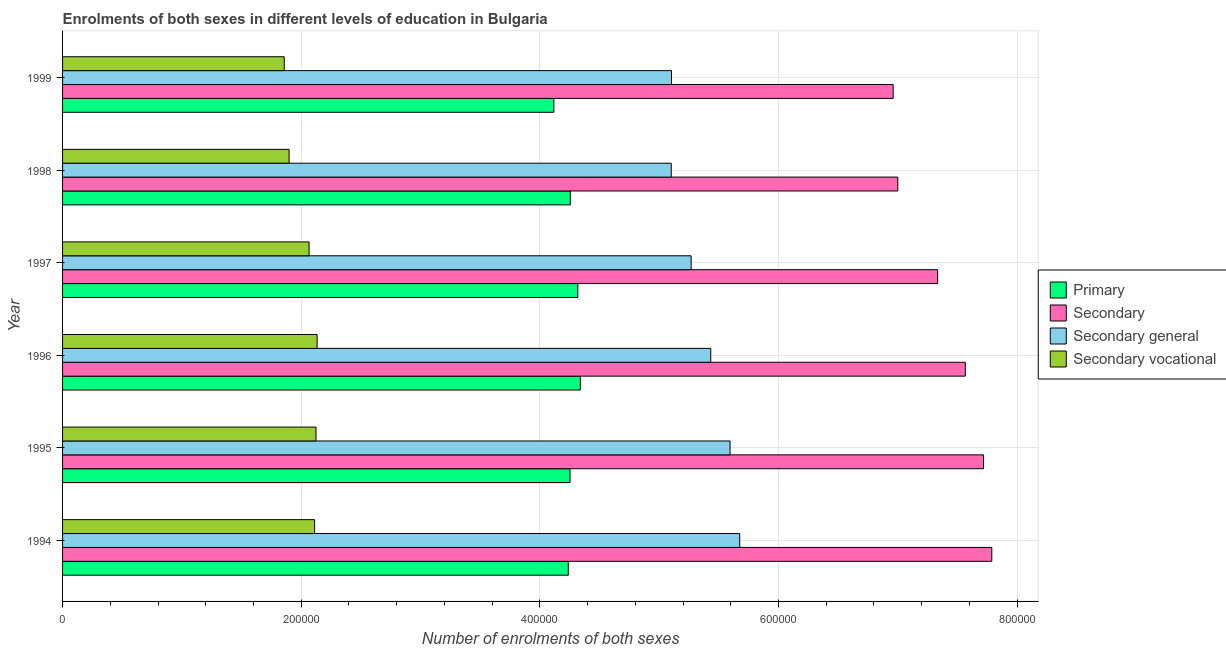How many different coloured bars are there?
Give a very brief answer. 4. How many groups of bars are there?
Offer a terse response. 6. Are the number of bars on each tick of the Y-axis equal?
Offer a very short reply. Yes. How many bars are there on the 6th tick from the bottom?
Offer a terse response. 4. What is the number of enrolments in secondary education in 1997?
Give a very brief answer. 7.33e+05. Across all years, what is the maximum number of enrolments in secondary education?
Give a very brief answer. 7.79e+05. Across all years, what is the minimum number of enrolments in secondary vocational education?
Provide a succinct answer. 1.86e+05. In which year was the number of enrolments in secondary vocational education maximum?
Give a very brief answer. 1996. What is the total number of enrolments in secondary general education in the graph?
Give a very brief answer. 3.22e+06. What is the difference between the number of enrolments in secondary general education in 1994 and that in 1996?
Keep it short and to the point. 2.43e+04. What is the difference between the number of enrolments in secondary general education in 1996 and the number of enrolments in primary education in 1998?
Give a very brief answer. 1.18e+05. What is the average number of enrolments in secondary education per year?
Offer a terse response. 7.39e+05. In the year 1998, what is the difference between the number of enrolments in secondary education and number of enrolments in primary education?
Offer a very short reply. 2.74e+05. What is the ratio of the number of enrolments in primary education in 1994 to that in 1997?
Offer a terse response. 0.98. What is the difference between the highest and the second highest number of enrolments in primary education?
Make the answer very short. 2136. What is the difference between the highest and the lowest number of enrolments in secondary education?
Give a very brief answer. 8.27e+04. What does the 4th bar from the top in 1999 represents?
Ensure brevity in your answer.  Primary. What does the 1st bar from the bottom in 1995 represents?
Your response must be concise. Primary. Are all the bars in the graph horizontal?
Make the answer very short. Yes. What is the difference between two consecutive major ticks on the X-axis?
Your answer should be very brief. 2.00e+05. Does the graph contain any zero values?
Provide a succinct answer. No. Where does the legend appear in the graph?
Make the answer very short. Center right. How many legend labels are there?
Make the answer very short. 4. How are the legend labels stacked?
Give a very brief answer. Vertical. What is the title of the graph?
Provide a succinct answer. Enrolments of both sexes in different levels of education in Bulgaria. What is the label or title of the X-axis?
Provide a short and direct response. Number of enrolments of both sexes. What is the Number of enrolments of both sexes in Primary in 1994?
Offer a terse response. 4.24e+05. What is the Number of enrolments of both sexes in Secondary in 1994?
Give a very brief answer. 7.79e+05. What is the Number of enrolments of both sexes of Secondary general in 1994?
Offer a very short reply. 5.68e+05. What is the Number of enrolments of both sexes in Secondary vocational in 1994?
Your answer should be compact. 2.11e+05. What is the Number of enrolments of both sexes of Primary in 1995?
Ensure brevity in your answer.  4.25e+05. What is the Number of enrolments of both sexes of Secondary in 1995?
Offer a very short reply. 7.72e+05. What is the Number of enrolments of both sexes of Secondary general in 1995?
Offer a very short reply. 5.59e+05. What is the Number of enrolments of both sexes of Secondary vocational in 1995?
Your response must be concise. 2.12e+05. What is the Number of enrolments of both sexes in Primary in 1996?
Your answer should be very brief. 4.34e+05. What is the Number of enrolments of both sexes in Secondary in 1996?
Provide a short and direct response. 7.57e+05. What is the Number of enrolments of both sexes in Secondary general in 1996?
Ensure brevity in your answer.  5.43e+05. What is the Number of enrolments of both sexes in Secondary vocational in 1996?
Provide a succinct answer. 2.13e+05. What is the Number of enrolments of both sexes in Primary in 1997?
Offer a very short reply. 4.32e+05. What is the Number of enrolments of both sexes of Secondary in 1997?
Make the answer very short. 7.33e+05. What is the Number of enrolments of both sexes in Secondary general in 1997?
Your response must be concise. 5.27e+05. What is the Number of enrolments of both sexes in Secondary vocational in 1997?
Your answer should be very brief. 2.07e+05. What is the Number of enrolments of both sexes in Primary in 1998?
Offer a very short reply. 4.26e+05. What is the Number of enrolments of both sexes in Secondary in 1998?
Provide a short and direct response. 7.00e+05. What is the Number of enrolments of both sexes in Secondary general in 1998?
Provide a succinct answer. 5.10e+05. What is the Number of enrolments of both sexes of Secondary vocational in 1998?
Offer a terse response. 1.90e+05. What is the Number of enrolments of both sexes in Primary in 1999?
Ensure brevity in your answer.  4.12e+05. What is the Number of enrolments of both sexes of Secondary in 1999?
Ensure brevity in your answer.  6.96e+05. What is the Number of enrolments of both sexes in Secondary general in 1999?
Ensure brevity in your answer.  5.10e+05. What is the Number of enrolments of both sexes in Secondary vocational in 1999?
Keep it short and to the point. 1.86e+05. Across all years, what is the maximum Number of enrolments of both sexes in Primary?
Your answer should be very brief. 4.34e+05. Across all years, what is the maximum Number of enrolments of both sexes of Secondary?
Ensure brevity in your answer.  7.79e+05. Across all years, what is the maximum Number of enrolments of both sexes of Secondary general?
Your response must be concise. 5.68e+05. Across all years, what is the maximum Number of enrolments of both sexes of Secondary vocational?
Make the answer very short. 2.13e+05. Across all years, what is the minimum Number of enrolments of both sexes of Primary?
Make the answer very short. 4.12e+05. Across all years, what is the minimum Number of enrolments of both sexes of Secondary?
Your answer should be very brief. 6.96e+05. Across all years, what is the minimum Number of enrolments of both sexes of Secondary general?
Ensure brevity in your answer.  5.10e+05. Across all years, what is the minimum Number of enrolments of both sexes in Secondary vocational?
Ensure brevity in your answer.  1.86e+05. What is the total Number of enrolments of both sexes of Primary in the graph?
Your response must be concise. 2.55e+06. What is the total Number of enrolments of both sexes of Secondary in the graph?
Ensure brevity in your answer.  4.44e+06. What is the total Number of enrolments of both sexes in Secondary general in the graph?
Your response must be concise. 3.22e+06. What is the total Number of enrolments of both sexes of Secondary vocational in the graph?
Make the answer very short. 1.22e+06. What is the difference between the Number of enrolments of both sexes of Primary in 1994 and that in 1995?
Offer a very short reply. -1468. What is the difference between the Number of enrolments of both sexes in Secondary in 1994 and that in 1995?
Give a very brief answer. 6939. What is the difference between the Number of enrolments of both sexes in Secondary general in 1994 and that in 1995?
Ensure brevity in your answer.  8105. What is the difference between the Number of enrolments of both sexes in Secondary vocational in 1994 and that in 1995?
Offer a terse response. -1166. What is the difference between the Number of enrolments of both sexes in Primary in 1994 and that in 1996?
Your answer should be compact. -1.01e+04. What is the difference between the Number of enrolments of both sexes of Secondary in 1994 and that in 1996?
Give a very brief answer. 2.22e+04. What is the difference between the Number of enrolments of both sexes of Secondary general in 1994 and that in 1996?
Ensure brevity in your answer.  2.43e+04. What is the difference between the Number of enrolments of both sexes of Secondary vocational in 1994 and that in 1996?
Your response must be concise. -2102. What is the difference between the Number of enrolments of both sexes of Primary in 1994 and that in 1997?
Provide a short and direct response. -7972. What is the difference between the Number of enrolments of both sexes in Secondary in 1994 and that in 1997?
Keep it short and to the point. 4.54e+04. What is the difference between the Number of enrolments of both sexes of Secondary general in 1994 and that in 1997?
Your answer should be compact. 4.07e+04. What is the difference between the Number of enrolments of both sexes of Secondary vocational in 1994 and that in 1997?
Offer a terse response. 4665. What is the difference between the Number of enrolments of both sexes of Primary in 1994 and that in 1998?
Make the answer very short. -1693. What is the difference between the Number of enrolments of both sexes in Secondary in 1994 and that in 1998?
Give a very brief answer. 7.88e+04. What is the difference between the Number of enrolments of both sexes of Secondary general in 1994 and that in 1998?
Make the answer very short. 5.74e+04. What is the difference between the Number of enrolments of both sexes in Secondary vocational in 1994 and that in 1998?
Make the answer very short. 2.14e+04. What is the difference between the Number of enrolments of both sexes in Primary in 1994 and that in 1999?
Give a very brief answer. 1.21e+04. What is the difference between the Number of enrolments of both sexes of Secondary in 1994 and that in 1999?
Provide a short and direct response. 8.27e+04. What is the difference between the Number of enrolments of both sexes of Secondary general in 1994 and that in 1999?
Give a very brief answer. 5.72e+04. What is the difference between the Number of enrolments of both sexes in Secondary vocational in 1994 and that in 1999?
Offer a very short reply. 2.55e+04. What is the difference between the Number of enrolments of both sexes in Primary in 1995 and that in 1996?
Keep it short and to the point. -8640. What is the difference between the Number of enrolments of both sexes in Secondary in 1995 and that in 1996?
Provide a succinct answer. 1.53e+04. What is the difference between the Number of enrolments of both sexes of Secondary general in 1995 and that in 1996?
Offer a very short reply. 1.62e+04. What is the difference between the Number of enrolments of both sexes of Secondary vocational in 1995 and that in 1996?
Provide a succinct answer. -936. What is the difference between the Number of enrolments of both sexes of Primary in 1995 and that in 1997?
Your answer should be compact. -6504. What is the difference between the Number of enrolments of both sexes in Secondary in 1995 and that in 1997?
Provide a succinct answer. 3.84e+04. What is the difference between the Number of enrolments of both sexes in Secondary general in 1995 and that in 1997?
Keep it short and to the point. 3.26e+04. What is the difference between the Number of enrolments of both sexes in Secondary vocational in 1995 and that in 1997?
Give a very brief answer. 5831. What is the difference between the Number of enrolments of both sexes of Primary in 1995 and that in 1998?
Keep it short and to the point. -225. What is the difference between the Number of enrolments of both sexes in Secondary in 1995 and that in 1998?
Your answer should be very brief. 7.18e+04. What is the difference between the Number of enrolments of both sexes of Secondary general in 1995 and that in 1998?
Provide a succinct answer. 4.93e+04. What is the difference between the Number of enrolments of both sexes in Secondary vocational in 1995 and that in 1998?
Provide a succinct answer. 2.26e+04. What is the difference between the Number of enrolments of both sexes of Primary in 1995 and that in 1999?
Give a very brief answer. 1.36e+04. What is the difference between the Number of enrolments of both sexes of Secondary in 1995 and that in 1999?
Keep it short and to the point. 7.57e+04. What is the difference between the Number of enrolments of both sexes of Secondary general in 1995 and that in 1999?
Offer a terse response. 4.91e+04. What is the difference between the Number of enrolments of both sexes of Secondary vocational in 1995 and that in 1999?
Provide a succinct answer. 2.66e+04. What is the difference between the Number of enrolments of both sexes of Primary in 1996 and that in 1997?
Offer a very short reply. 2136. What is the difference between the Number of enrolments of both sexes in Secondary in 1996 and that in 1997?
Give a very brief answer. 2.32e+04. What is the difference between the Number of enrolments of both sexes of Secondary general in 1996 and that in 1997?
Provide a succinct answer. 1.64e+04. What is the difference between the Number of enrolments of both sexes in Secondary vocational in 1996 and that in 1997?
Give a very brief answer. 6767. What is the difference between the Number of enrolments of both sexes of Primary in 1996 and that in 1998?
Your response must be concise. 8415. What is the difference between the Number of enrolments of both sexes of Secondary in 1996 and that in 1998?
Offer a terse response. 5.66e+04. What is the difference between the Number of enrolments of both sexes in Secondary general in 1996 and that in 1998?
Offer a terse response. 3.31e+04. What is the difference between the Number of enrolments of both sexes of Secondary vocational in 1996 and that in 1998?
Ensure brevity in your answer.  2.35e+04. What is the difference between the Number of enrolments of both sexes in Primary in 1996 and that in 1999?
Provide a succinct answer. 2.22e+04. What is the difference between the Number of enrolments of both sexes of Secondary in 1996 and that in 1999?
Keep it short and to the point. 6.05e+04. What is the difference between the Number of enrolments of both sexes of Secondary general in 1996 and that in 1999?
Provide a succinct answer. 3.29e+04. What is the difference between the Number of enrolments of both sexes in Secondary vocational in 1996 and that in 1999?
Your answer should be compact. 2.76e+04. What is the difference between the Number of enrolments of both sexes of Primary in 1997 and that in 1998?
Keep it short and to the point. 6279. What is the difference between the Number of enrolments of both sexes in Secondary in 1997 and that in 1998?
Your answer should be compact. 3.34e+04. What is the difference between the Number of enrolments of both sexes in Secondary general in 1997 and that in 1998?
Your answer should be compact. 1.67e+04. What is the difference between the Number of enrolments of both sexes of Secondary vocational in 1997 and that in 1998?
Offer a very short reply. 1.67e+04. What is the difference between the Number of enrolments of both sexes in Primary in 1997 and that in 1999?
Your response must be concise. 2.01e+04. What is the difference between the Number of enrolments of both sexes in Secondary in 1997 and that in 1999?
Your response must be concise. 3.73e+04. What is the difference between the Number of enrolments of both sexes of Secondary general in 1997 and that in 1999?
Give a very brief answer. 1.65e+04. What is the difference between the Number of enrolments of both sexes of Secondary vocational in 1997 and that in 1999?
Provide a short and direct response. 2.08e+04. What is the difference between the Number of enrolments of both sexes of Primary in 1998 and that in 1999?
Provide a short and direct response. 1.38e+04. What is the difference between the Number of enrolments of both sexes in Secondary in 1998 and that in 1999?
Offer a terse response. 3884. What is the difference between the Number of enrolments of both sexes of Secondary general in 1998 and that in 1999?
Your answer should be compact. -215. What is the difference between the Number of enrolments of both sexes of Secondary vocational in 1998 and that in 1999?
Your response must be concise. 4099. What is the difference between the Number of enrolments of both sexes of Primary in 1994 and the Number of enrolments of both sexes of Secondary in 1995?
Provide a succinct answer. -3.48e+05. What is the difference between the Number of enrolments of both sexes in Primary in 1994 and the Number of enrolments of both sexes in Secondary general in 1995?
Your response must be concise. -1.36e+05. What is the difference between the Number of enrolments of both sexes in Primary in 1994 and the Number of enrolments of both sexes in Secondary vocational in 1995?
Your response must be concise. 2.11e+05. What is the difference between the Number of enrolments of both sexes in Secondary in 1994 and the Number of enrolments of both sexes in Secondary general in 1995?
Your answer should be very brief. 2.19e+05. What is the difference between the Number of enrolments of both sexes of Secondary in 1994 and the Number of enrolments of both sexes of Secondary vocational in 1995?
Provide a short and direct response. 5.66e+05. What is the difference between the Number of enrolments of both sexes of Secondary general in 1994 and the Number of enrolments of both sexes of Secondary vocational in 1995?
Your answer should be very brief. 3.55e+05. What is the difference between the Number of enrolments of both sexes of Primary in 1994 and the Number of enrolments of both sexes of Secondary in 1996?
Give a very brief answer. -3.33e+05. What is the difference between the Number of enrolments of both sexes in Primary in 1994 and the Number of enrolments of both sexes in Secondary general in 1996?
Your response must be concise. -1.19e+05. What is the difference between the Number of enrolments of both sexes in Primary in 1994 and the Number of enrolments of both sexes in Secondary vocational in 1996?
Your response must be concise. 2.10e+05. What is the difference between the Number of enrolments of both sexes in Secondary in 1994 and the Number of enrolments of both sexes in Secondary general in 1996?
Make the answer very short. 2.36e+05. What is the difference between the Number of enrolments of both sexes in Secondary in 1994 and the Number of enrolments of both sexes in Secondary vocational in 1996?
Offer a terse response. 5.65e+05. What is the difference between the Number of enrolments of both sexes in Secondary general in 1994 and the Number of enrolments of both sexes in Secondary vocational in 1996?
Offer a very short reply. 3.54e+05. What is the difference between the Number of enrolments of both sexes in Primary in 1994 and the Number of enrolments of both sexes in Secondary in 1997?
Provide a succinct answer. -3.10e+05. What is the difference between the Number of enrolments of both sexes in Primary in 1994 and the Number of enrolments of both sexes in Secondary general in 1997?
Your answer should be very brief. -1.03e+05. What is the difference between the Number of enrolments of both sexes in Primary in 1994 and the Number of enrolments of both sexes in Secondary vocational in 1997?
Offer a very short reply. 2.17e+05. What is the difference between the Number of enrolments of both sexes of Secondary in 1994 and the Number of enrolments of both sexes of Secondary general in 1997?
Give a very brief answer. 2.52e+05. What is the difference between the Number of enrolments of both sexes of Secondary in 1994 and the Number of enrolments of both sexes of Secondary vocational in 1997?
Your answer should be compact. 5.72e+05. What is the difference between the Number of enrolments of both sexes of Secondary general in 1994 and the Number of enrolments of both sexes of Secondary vocational in 1997?
Ensure brevity in your answer.  3.61e+05. What is the difference between the Number of enrolments of both sexes in Primary in 1994 and the Number of enrolments of both sexes in Secondary in 1998?
Your response must be concise. -2.76e+05. What is the difference between the Number of enrolments of both sexes in Primary in 1994 and the Number of enrolments of both sexes in Secondary general in 1998?
Offer a very short reply. -8.63e+04. What is the difference between the Number of enrolments of both sexes of Primary in 1994 and the Number of enrolments of both sexes of Secondary vocational in 1998?
Your response must be concise. 2.34e+05. What is the difference between the Number of enrolments of both sexes of Secondary in 1994 and the Number of enrolments of both sexes of Secondary general in 1998?
Provide a succinct answer. 2.69e+05. What is the difference between the Number of enrolments of both sexes in Secondary in 1994 and the Number of enrolments of both sexes in Secondary vocational in 1998?
Your response must be concise. 5.89e+05. What is the difference between the Number of enrolments of both sexes in Secondary general in 1994 and the Number of enrolments of both sexes in Secondary vocational in 1998?
Keep it short and to the point. 3.78e+05. What is the difference between the Number of enrolments of both sexes in Primary in 1994 and the Number of enrolments of both sexes in Secondary in 1999?
Provide a succinct answer. -2.72e+05. What is the difference between the Number of enrolments of both sexes in Primary in 1994 and the Number of enrolments of both sexes in Secondary general in 1999?
Give a very brief answer. -8.65e+04. What is the difference between the Number of enrolments of both sexes of Primary in 1994 and the Number of enrolments of both sexes of Secondary vocational in 1999?
Ensure brevity in your answer.  2.38e+05. What is the difference between the Number of enrolments of both sexes in Secondary in 1994 and the Number of enrolments of both sexes in Secondary general in 1999?
Your response must be concise. 2.68e+05. What is the difference between the Number of enrolments of both sexes of Secondary in 1994 and the Number of enrolments of both sexes of Secondary vocational in 1999?
Give a very brief answer. 5.93e+05. What is the difference between the Number of enrolments of both sexes in Secondary general in 1994 and the Number of enrolments of both sexes in Secondary vocational in 1999?
Provide a succinct answer. 3.82e+05. What is the difference between the Number of enrolments of both sexes in Primary in 1995 and the Number of enrolments of both sexes in Secondary in 1996?
Keep it short and to the point. -3.31e+05. What is the difference between the Number of enrolments of both sexes in Primary in 1995 and the Number of enrolments of both sexes in Secondary general in 1996?
Offer a terse response. -1.18e+05. What is the difference between the Number of enrolments of both sexes in Primary in 1995 and the Number of enrolments of both sexes in Secondary vocational in 1996?
Your answer should be compact. 2.12e+05. What is the difference between the Number of enrolments of both sexes of Secondary in 1995 and the Number of enrolments of both sexes of Secondary general in 1996?
Your answer should be very brief. 2.29e+05. What is the difference between the Number of enrolments of both sexes in Secondary in 1995 and the Number of enrolments of both sexes in Secondary vocational in 1996?
Provide a succinct answer. 5.58e+05. What is the difference between the Number of enrolments of both sexes of Secondary general in 1995 and the Number of enrolments of both sexes of Secondary vocational in 1996?
Provide a short and direct response. 3.46e+05. What is the difference between the Number of enrolments of both sexes of Primary in 1995 and the Number of enrolments of both sexes of Secondary in 1997?
Your response must be concise. -3.08e+05. What is the difference between the Number of enrolments of both sexes in Primary in 1995 and the Number of enrolments of both sexes in Secondary general in 1997?
Keep it short and to the point. -1.02e+05. What is the difference between the Number of enrolments of both sexes of Primary in 1995 and the Number of enrolments of both sexes of Secondary vocational in 1997?
Your answer should be compact. 2.19e+05. What is the difference between the Number of enrolments of both sexes of Secondary in 1995 and the Number of enrolments of both sexes of Secondary general in 1997?
Make the answer very short. 2.45e+05. What is the difference between the Number of enrolments of both sexes of Secondary in 1995 and the Number of enrolments of both sexes of Secondary vocational in 1997?
Ensure brevity in your answer.  5.65e+05. What is the difference between the Number of enrolments of both sexes in Secondary general in 1995 and the Number of enrolments of both sexes in Secondary vocational in 1997?
Provide a succinct answer. 3.53e+05. What is the difference between the Number of enrolments of both sexes of Primary in 1995 and the Number of enrolments of both sexes of Secondary in 1998?
Offer a terse response. -2.75e+05. What is the difference between the Number of enrolments of both sexes of Primary in 1995 and the Number of enrolments of both sexes of Secondary general in 1998?
Make the answer very short. -8.48e+04. What is the difference between the Number of enrolments of both sexes in Primary in 1995 and the Number of enrolments of both sexes in Secondary vocational in 1998?
Your response must be concise. 2.35e+05. What is the difference between the Number of enrolments of both sexes of Secondary in 1995 and the Number of enrolments of both sexes of Secondary general in 1998?
Offer a terse response. 2.62e+05. What is the difference between the Number of enrolments of both sexes in Secondary in 1995 and the Number of enrolments of both sexes in Secondary vocational in 1998?
Make the answer very short. 5.82e+05. What is the difference between the Number of enrolments of both sexes in Secondary general in 1995 and the Number of enrolments of both sexes in Secondary vocational in 1998?
Provide a short and direct response. 3.70e+05. What is the difference between the Number of enrolments of both sexes in Primary in 1995 and the Number of enrolments of both sexes in Secondary in 1999?
Your answer should be compact. -2.71e+05. What is the difference between the Number of enrolments of both sexes in Primary in 1995 and the Number of enrolments of both sexes in Secondary general in 1999?
Make the answer very short. -8.50e+04. What is the difference between the Number of enrolments of both sexes in Primary in 1995 and the Number of enrolments of both sexes in Secondary vocational in 1999?
Give a very brief answer. 2.40e+05. What is the difference between the Number of enrolments of both sexes of Secondary in 1995 and the Number of enrolments of both sexes of Secondary general in 1999?
Your answer should be very brief. 2.61e+05. What is the difference between the Number of enrolments of both sexes of Secondary in 1995 and the Number of enrolments of both sexes of Secondary vocational in 1999?
Offer a very short reply. 5.86e+05. What is the difference between the Number of enrolments of both sexes of Secondary general in 1995 and the Number of enrolments of both sexes of Secondary vocational in 1999?
Offer a very short reply. 3.74e+05. What is the difference between the Number of enrolments of both sexes of Primary in 1996 and the Number of enrolments of both sexes of Secondary in 1997?
Your response must be concise. -2.99e+05. What is the difference between the Number of enrolments of both sexes of Primary in 1996 and the Number of enrolments of both sexes of Secondary general in 1997?
Your response must be concise. -9.29e+04. What is the difference between the Number of enrolments of both sexes of Primary in 1996 and the Number of enrolments of both sexes of Secondary vocational in 1997?
Make the answer very short. 2.27e+05. What is the difference between the Number of enrolments of both sexes of Secondary in 1996 and the Number of enrolments of both sexes of Secondary general in 1997?
Offer a terse response. 2.30e+05. What is the difference between the Number of enrolments of both sexes in Secondary in 1996 and the Number of enrolments of both sexes in Secondary vocational in 1997?
Offer a very short reply. 5.50e+05. What is the difference between the Number of enrolments of both sexes in Secondary general in 1996 and the Number of enrolments of both sexes in Secondary vocational in 1997?
Give a very brief answer. 3.37e+05. What is the difference between the Number of enrolments of both sexes of Primary in 1996 and the Number of enrolments of both sexes of Secondary in 1998?
Provide a short and direct response. -2.66e+05. What is the difference between the Number of enrolments of both sexes in Primary in 1996 and the Number of enrolments of both sexes in Secondary general in 1998?
Keep it short and to the point. -7.62e+04. What is the difference between the Number of enrolments of both sexes in Primary in 1996 and the Number of enrolments of both sexes in Secondary vocational in 1998?
Give a very brief answer. 2.44e+05. What is the difference between the Number of enrolments of both sexes in Secondary in 1996 and the Number of enrolments of both sexes in Secondary general in 1998?
Provide a succinct answer. 2.46e+05. What is the difference between the Number of enrolments of both sexes in Secondary in 1996 and the Number of enrolments of both sexes in Secondary vocational in 1998?
Keep it short and to the point. 5.67e+05. What is the difference between the Number of enrolments of both sexes of Secondary general in 1996 and the Number of enrolments of both sexes of Secondary vocational in 1998?
Provide a succinct answer. 3.53e+05. What is the difference between the Number of enrolments of both sexes in Primary in 1996 and the Number of enrolments of both sexes in Secondary in 1999?
Offer a very short reply. -2.62e+05. What is the difference between the Number of enrolments of both sexes of Primary in 1996 and the Number of enrolments of both sexes of Secondary general in 1999?
Give a very brief answer. -7.64e+04. What is the difference between the Number of enrolments of both sexes of Primary in 1996 and the Number of enrolments of both sexes of Secondary vocational in 1999?
Offer a very short reply. 2.48e+05. What is the difference between the Number of enrolments of both sexes of Secondary in 1996 and the Number of enrolments of both sexes of Secondary general in 1999?
Provide a succinct answer. 2.46e+05. What is the difference between the Number of enrolments of both sexes in Secondary in 1996 and the Number of enrolments of both sexes in Secondary vocational in 1999?
Make the answer very short. 5.71e+05. What is the difference between the Number of enrolments of both sexes of Secondary general in 1996 and the Number of enrolments of both sexes of Secondary vocational in 1999?
Give a very brief answer. 3.57e+05. What is the difference between the Number of enrolments of both sexes in Primary in 1997 and the Number of enrolments of both sexes in Secondary in 1998?
Your response must be concise. -2.68e+05. What is the difference between the Number of enrolments of both sexes in Primary in 1997 and the Number of enrolments of both sexes in Secondary general in 1998?
Keep it short and to the point. -7.83e+04. What is the difference between the Number of enrolments of both sexes in Primary in 1997 and the Number of enrolments of both sexes in Secondary vocational in 1998?
Your response must be concise. 2.42e+05. What is the difference between the Number of enrolments of both sexes in Secondary in 1997 and the Number of enrolments of both sexes in Secondary general in 1998?
Make the answer very short. 2.23e+05. What is the difference between the Number of enrolments of both sexes in Secondary in 1997 and the Number of enrolments of both sexes in Secondary vocational in 1998?
Keep it short and to the point. 5.44e+05. What is the difference between the Number of enrolments of both sexes in Secondary general in 1997 and the Number of enrolments of both sexes in Secondary vocational in 1998?
Offer a very short reply. 3.37e+05. What is the difference between the Number of enrolments of both sexes in Primary in 1997 and the Number of enrolments of both sexes in Secondary in 1999?
Ensure brevity in your answer.  -2.64e+05. What is the difference between the Number of enrolments of both sexes in Primary in 1997 and the Number of enrolments of both sexes in Secondary general in 1999?
Provide a short and direct response. -7.85e+04. What is the difference between the Number of enrolments of both sexes of Primary in 1997 and the Number of enrolments of both sexes of Secondary vocational in 1999?
Make the answer very short. 2.46e+05. What is the difference between the Number of enrolments of both sexes of Secondary in 1997 and the Number of enrolments of both sexes of Secondary general in 1999?
Your answer should be compact. 2.23e+05. What is the difference between the Number of enrolments of both sexes in Secondary in 1997 and the Number of enrolments of both sexes in Secondary vocational in 1999?
Ensure brevity in your answer.  5.48e+05. What is the difference between the Number of enrolments of both sexes of Secondary general in 1997 and the Number of enrolments of both sexes of Secondary vocational in 1999?
Keep it short and to the point. 3.41e+05. What is the difference between the Number of enrolments of both sexes in Primary in 1998 and the Number of enrolments of both sexes in Secondary in 1999?
Your answer should be compact. -2.71e+05. What is the difference between the Number of enrolments of both sexes of Primary in 1998 and the Number of enrolments of both sexes of Secondary general in 1999?
Your answer should be compact. -8.48e+04. What is the difference between the Number of enrolments of both sexes in Primary in 1998 and the Number of enrolments of both sexes in Secondary vocational in 1999?
Ensure brevity in your answer.  2.40e+05. What is the difference between the Number of enrolments of both sexes in Secondary in 1998 and the Number of enrolments of both sexes in Secondary general in 1999?
Your answer should be compact. 1.90e+05. What is the difference between the Number of enrolments of both sexes in Secondary in 1998 and the Number of enrolments of both sexes in Secondary vocational in 1999?
Offer a very short reply. 5.14e+05. What is the difference between the Number of enrolments of both sexes in Secondary general in 1998 and the Number of enrolments of both sexes in Secondary vocational in 1999?
Keep it short and to the point. 3.24e+05. What is the average Number of enrolments of both sexes in Primary per year?
Offer a terse response. 4.25e+05. What is the average Number of enrolments of both sexes of Secondary per year?
Offer a terse response. 7.39e+05. What is the average Number of enrolments of both sexes in Secondary general per year?
Keep it short and to the point. 5.36e+05. What is the average Number of enrolments of both sexes in Secondary vocational per year?
Provide a short and direct response. 2.03e+05. In the year 1994, what is the difference between the Number of enrolments of both sexes in Primary and Number of enrolments of both sexes in Secondary?
Provide a short and direct response. -3.55e+05. In the year 1994, what is the difference between the Number of enrolments of both sexes of Primary and Number of enrolments of both sexes of Secondary general?
Your response must be concise. -1.44e+05. In the year 1994, what is the difference between the Number of enrolments of both sexes in Primary and Number of enrolments of both sexes in Secondary vocational?
Make the answer very short. 2.13e+05. In the year 1994, what is the difference between the Number of enrolments of both sexes in Secondary and Number of enrolments of both sexes in Secondary general?
Ensure brevity in your answer.  2.11e+05. In the year 1994, what is the difference between the Number of enrolments of both sexes of Secondary and Number of enrolments of both sexes of Secondary vocational?
Give a very brief answer. 5.68e+05. In the year 1994, what is the difference between the Number of enrolments of both sexes in Secondary general and Number of enrolments of both sexes in Secondary vocational?
Your response must be concise. 3.56e+05. In the year 1995, what is the difference between the Number of enrolments of both sexes of Primary and Number of enrolments of both sexes of Secondary?
Ensure brevity in your answer.  -3.47e+05. In the year 1995, what is the difference between the Number of enrolments of both sexes in Primary and Number of enrolments of both sexes in Secondary general?
Your answer should be compact. -1.34e+05. In the year 1995, what is the difference between the Number of enrolments of both sexes in Primary and Number of enrolments of both sexes in Secondary vocational?
Provide a short and direct response. 2.13e+05. In the year 1995, what is the difference between the Number of enrolments of both sexes in Secondary and Number of enrolments of both sexes in Secondary general?
Provide a succinct answer. 2.12e+05. In the year 1995, what is the difference between the Number of enrolments of both sexes of Secondary and Number of enrolments of both sexes of Secondary vocational?
Your answer should be compact. 5.59e+05. In the year 1995, what is the difference between the Number of enrolments of both sexes of Secondary general and Number of enrolments of both sexes of Secondary vocational?
Your answer should be very brief. 3.47e+05. In the year 1996, what is the difference between the Number of enrolments of both sexes in Primary and Number of enrolments of both sexes in Secondary?
Provide a short and direct response. -3.23e+05. In the year 1996, what is the difference between the Number of enrolments of both sexes of Primary and Number of enrolments of both sexes of Secondary general?
Ensure brevity in your answer.  -1.09e+05. In the year 1996, what is the difference between the Number of enrolments of both sexes of Primary and Number of enrolments of both sexes of Secondary vocational?
Give a very brief answer. 2.21e+05. In the year 1996, what is the difference between the Number of enrolments of both sexes in Secondary and Number of enrolments of both sexes in Secondary general?
Your answer should be very brief. 2.13e+05. In the year 1996, what is the difference between the Number of enrolments of both sexes in Secondary and Number of enrolments of both sexes in Secondary vocational?
Your answer should be compact. 5.43e+05. In the year 1996, what is the difference between the Number of enrolments of both sexes of Secondary general and Number of enrolments of both sexes of Secondary vocational?
Your answer should be compact. 3.30e+05. In the year 1997, what is the difference between the Number of enrolments of both sexes of Primary and Number of enrolments of both sexes of Secondary?
Ensure brevity in your answer.  -3.02e+05. In the year 1997, what is the difference between the Number of enrolments of both sexes of Primary and Number of enrolments of both sexes of Secondary general?
Ensure brevity in your answer.  -9.50e+04. In the year 1997, what is the difference between the Number of enrolments of both sexes in Primary and Number of enrolments of both sexes in Secondary vocational?
Offer a very short reply. 2.25e+05. In the year 1997, what is the difference between the Number of enrolments of both sexes of Secondary and Number of enrolments of both sexes of Secondary general?
Provide a short and direct response. 2.07e+05. In the year 1997, what is the difference between the Number of enrolments of both sexes in Secondary and Number of enrolments of both sexes in Secondary vocational?
Your response must be concise. 5.27e+05. In the year 1997, what is the difference between the Number of enrolments of both sexes of Secondary general and Number of enrolments of both sexes of Secondary vocational?
Make the answer very short. 3.20e+05. In the year 1998, what is the difference between the Number of enrolments of both sexes of Primary and Number of enrolments of both sexes of Secondary?
Provide a short and direct response. -2.74e+05. In the year 1998, what is the difference between the Number of enrolments of both sexes in Primary and Number of enrolments of both sexes in Secondary general?
Provide a succinct answer. -8.46e+04. In the year 1998, what is the difference between the Number of enrolments of both sexes in Primary and Number of enrolments of both sexes in Secondary vocational?
Your response must be concise. 2.36e+05. In the year 1998, what is the difference between the Number of enrolments of both sexes of Secondary and Number of enrolments of both sexes of Secondary general?
Provide a short and direct response. 1.90e+05. In the year 1998, what is the difference between the Number of enrolments of both sexes of Secondary and Number of enrolments of both sexes of Secondary vocational?
Your answer should be compact. 5.10e+05. In the year 1998, what is the difference between the Number of enrolments of both sexes in Secondary general and Number of enrolments of both sexes in Secondary vocational?
Ensure brevity in your answer.  3.20e+05. In the year 1999, what is the difference between the Number of enrolments of both sexes of Primary and Number of enrolments of both sexes of Secondary?
Keep it short and to the point. -2.84e+05. In the year 1999, what is the difference between the Number of enrolments of both sexes in Primary and Number of enrolments of both sexes in Secondary general?
Ensure brevity in your answer.  -9.86e+04. In the year 1999, what is the difference between the Number of enrolments of both sexes of Primary and Number of enrolments of both sexes of Secondary vocational?
Keep it short and to the point. 2.26e+05. In the year 1999, what is the difference between the Number of enrolments of both sexes in Secondary and Number of enrolments of both sexes in Secondary general?
Your answer should be very brief. 1.86e+05. In the year 1999, what is the difference between the Number of enrolments of both sexes in Secondary and Number of enrolments of both sexes in Secondary vocational?
Keep it short and to the point. 5.10e+05. In the year 1999, what is the difference between the Number of enrolments of both sexes of Secondary general and Number of enrolments of both sexes of Secondary vocational?
Keep it short and to the point. 3.25e+05. What is the ratio of the Number of enrolments of both sexes of Secondary in 1994 to that in 1995?
Ensure brevity in your answer.  1.01. What is the ratio of the Number of enrolments of both sexes of Secondary general in 1994 to that in 1995?
Offer a very short reply. 1.01. What is the ratio of the Number of enrolments of both sexes in Primary in 1994 to that in 1996?
Your answer should be compact. 0.98. What is the ratio of the Number of enrolments of both sexes in Secondary in 1994 to that in 1996?
Make the answer very short. 1.03. What is the ratio of the Number of enrolments of both sexes of Secondary general in 1994 to that in 1996?
Offer a terse response. 1.04. What is the ratio of the Number of enrolments of both sexes of Primary in 1994 to that in 1997?
Offer a terse response. 0.98. What is the ratio of the Number of enrolments of both sexes of Secondary in 1994 to that in 1997?
Make the answer very short. 1.06. What is the ratio of the Number of enrolments of both sexes of Secondary general in 1994 to that in 1997?
Provide a succinct answer. 1.08. What is the ratio of the Number of enrolments of both sexes in Secondary vocational in 1994 to that in 1997?
Offer a very short reply. 1.02. What is the ratio of the Number of enrolments of both sexes of Secondary in 1994 to that in 1998?
Ensure brevity in your answer.  1.11. What is the ratio of the Number of enrolments of both sexes of Secondary general in 1994 to that in 1998?
Your answer should be compact. 1.11. What is the ratio of the Number of enrolments of both sexes in Secondary vocational in 1994 to that in 1998?
Make the answer very short. 1.11. What is the ratio of the Number of enrolments of both sexes in Primary in 1994 to that in 1999?
Keep it short and to the point. 1.03. What is the ratio of the Number of enrolments of both sexes in Secondary in 1994 to that in 1999?
Keep it short and to the point. 1.12. What is the ratio of the Number of enrolments of both sexes in Secondary general in 1994 to that in 1999?
Your answer should be compact. 1.11. What is the ratio of the Number of enrolments of both sexes of Secondary vocational in 1994 to that in 1999?
Provide a succinct answer. 1.14. What is the ratio of the Number of enrolments of both sexes of Primary in 1995 to that in 1996?
Your answer should be compact. 0.98. What is the ratio of the Number of enrolments of both sexes of Secondary in 1995 to that in 1996?
Your answer should be compact. 1.02. What is the ratio of the Number of enrolments of both sexes in Secondary general in 1995 to that in 1996?
Make the answer very short. 1.03. What is the ratio of the Number of enrolments of both sexes of Primary in 1995 to that in 1997?
Provide a succinct answer. 0.98. What is the ratio of the Number of enrolments of both sexes of Secondary in 1995 to that in 1997?
Your response must be concise. 1.05. What is the ratio of the Number of enrolments of both sexes in Secondary general in 1995 to that in 1997?
Your response must be concise. 1.06. What is the ratio of the Number of enrolments of both sexes in Secondary vocational in 1995 to that in 1997?
Provide a short and direct response. 1.03. What is the ratio of the Number of enrolments of both sexes of Primary in 1995 to that in 1998?
Make the answer very short. 1. What is the ratio of the Number of enrolments of both sexes in Secondary in 1995 to that in 1998?
Your response must be concise. 1.1. What is the ratio of the Number of enrolments of both sexes of Secondary general in 1995 to that in 1998?
Provide a short and direct response. 1.1. What is the ratio of the Number of enrolments of both sexes in Secondary vocational in 1995 to that in 1998?
Keep it short and to the point. 1.12. What is the ratio of the Number of enrolments of both sexes in Primary in 1995 to that in 1999?
Make the answer very short. 1.03. What is the ratio of the Number of enrolments of both sexes in Secondary in 1995 to that in 1999?
Provide a succinct answer. 1.11. What is the ratio of the Number of enrolments of both sexes of Secondary general in 1995 to that in 1999?
Make the answer very short. 1.1. What is the ratio of the Number of enrolments of both sexes in Secondary vocational in 1995 to that in 1999?
Provide a short and direct response. 1.14. What is the ratio of the Number of enrolments of both sexes of Secondary in 1996 to that in 1997?
Your response must be concise. 1.03. What is the ratio of the Number of enrolments of both sexes in Secondary general in 1996 to that in 1997?
Keep it short and to the point. 1.03. What is the ratio of the Number of enrolments of both sexes in Secondary vocational in 1996 to that in 1997?
Offer a very short reply. 1.03. What is the ratio of the Number of enrolments of both sexes of Primary in 1996 to that in 1998?
Provide a succinct answer. 1.02. What is the ratio of the Number of enrolments of both sexes in Secondary in 1996 to that in 1998?
Provide a short and direct response. 1.08. What is the ratio of the Number of enrolments of both sexes in Secondary general in 1996 to that in 1998?
Give a very brief answer. 1.06. What is the ratio of the Number of enrolments of both sexes in Secondary vocational in 1996 to that in 1998?
Give a very brief answer. 1.12. What is the ratio of the Number of enrolments of both sexes of Primary in 1996 to that in 1999?
Give a very brief answer. 1.05. What is the ratio of the Number of enrolments of both sexes of Secondary in 1996 to that in 1999?
Offer a terse response. 1.09. What is the ratio of the Number of enrolments of both sexes in Secondary general in 1996 to that in 1999?
Your answer should be compact. 1.06. What is the ratio of the Number of enrolments of both sexes of Secondary vocational in 1996 to that in 1999?
Give a very brief answer. 1.15. What is the ratio of the Number of enrolments of both sexes of Primary in 1997 to that in 1998?
Make the answer very short. 1.01. What is the ratio of the Number of enrolments of both sexes of Secondary in 1997 to that in 1998?
Provide a short and direct response. 1.05. What is the ratio of the Number of enrolments of both sexes of Secondary general in 1997 to that in 1998?
Make the answer very short. 1.03. What is the ratio of the Number of enrolments of both sexes in Secondary vocational in 1997 to that in 1998?
Provide a short and direct response. 1.09. What is the ratio of the Number of enrolments of both sexes in Primary in 1997 to that in 1999?
Ensure brevity in your answer.  1.05. What is the ratio of the Number of enrolments of both sexes in Secondary in 1997 to that in 1999?
Offer a very short reply. 1.05. What is the ratio of the Number of enrolments of both sexes in Secondary general in 1997 to that in 1999?
Your answer should be compact. 1.03. What is the ratio of the Number of enrolments of both sexes of Secondary vocational in 1997 to that in 1999?
Your answer should be compact. 1.11. What is the ratio of the Number of enrolments of both sexes in Primary in 1998 to that in 1999?
Make the answer very short. 1.03. What is the ratio of the Number of enrolments of both sexes in Secondary in 1998 to that in 1999?
Provide a short and direct response. 1.01. What is the ratio of the Number of enrolments of both sexes in Secondary general in 1998 to that in 1999?
Provide a short and direct response. 1. What is the ratio of the Number of enrolments of both sexes of Secondary vocational in 1998 to that in 1999?
Ensure brevity in your answer.  1.02. What is the difference between the highest and the second highest Number of enrolments of both sexes of Primary?
Offer a terse response. 2136. What is the difference between the highest and the second highest Number of enrolments of both sexes of Secondary?
Provide a short and direct response. 6939. What is the difference between the highest and the second highest Number of enrolments of both sexes in Secondary general?
Your response must be concise. 8105. What is the difference between the highest and the second highest Number of enrolments of both sexes in Secondary vocational?
Provide a short and direct response. 936. What is the difference between the highest and the lowest Number of enrolments of both sexes of Primary?
Provide a short and direct response. 2.22e+04. What is the difference between the highest and the lowest Number of enrolments of both sexes in Secondary?
Give a very brief answer. 8.27e+04. What is the difference between the highest and the lowest Number of enrolments of both sexes in Secondary general?
Your answer should be compact. 5.74e+04. What is the difference between the highest and the lowest Number of enrolments of both sexes in Secondary vocational?
Make the answer very short. 2.76e+04. 